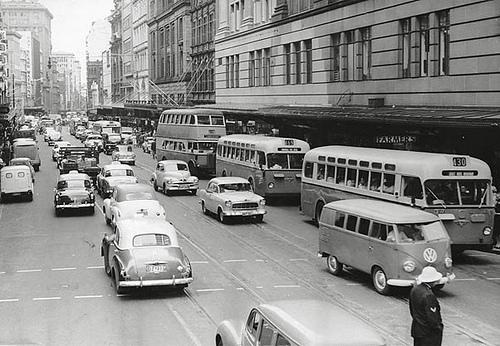Are the cars in motion?
Quick response, please. Yes. How many vans do you see?
Keep it brief. 1. Is this scene over two decades ago?
Be succinct. Yes. Are these real cars?
Be succinct. Yes. What make is the main car?
Quick response, please. Volkswagen. Are the cars parked?
Be succinct. No. Is there a police officer in this image?
Keep it brief. Yes. IS this a busy city street?
Quick response, please. Yes. 